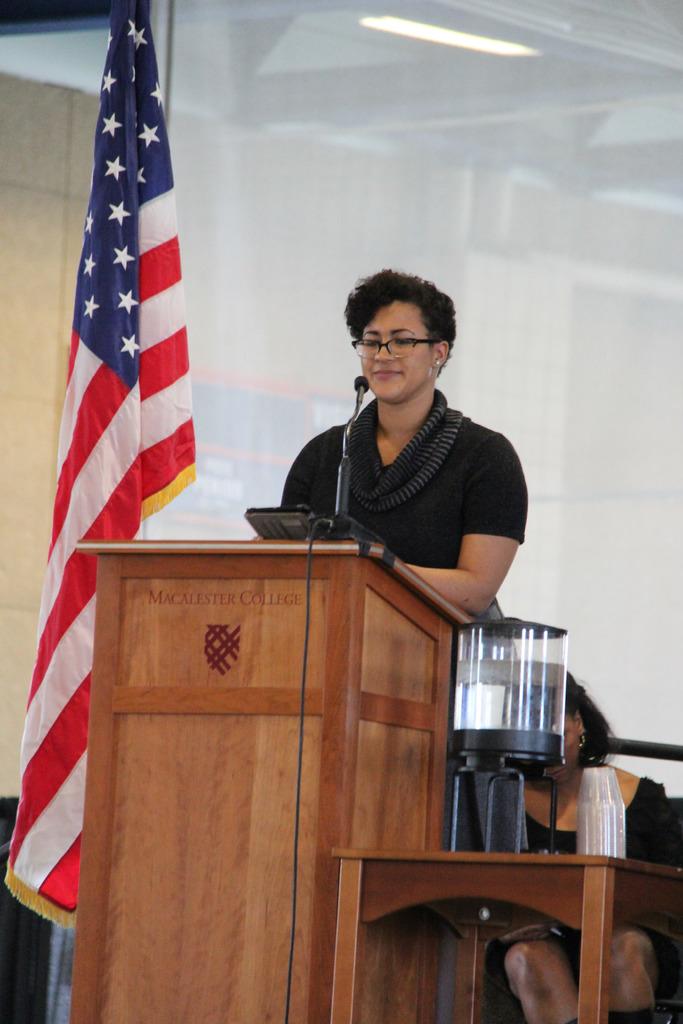What is the name of this college?
Your response must be concise. Macalester. 